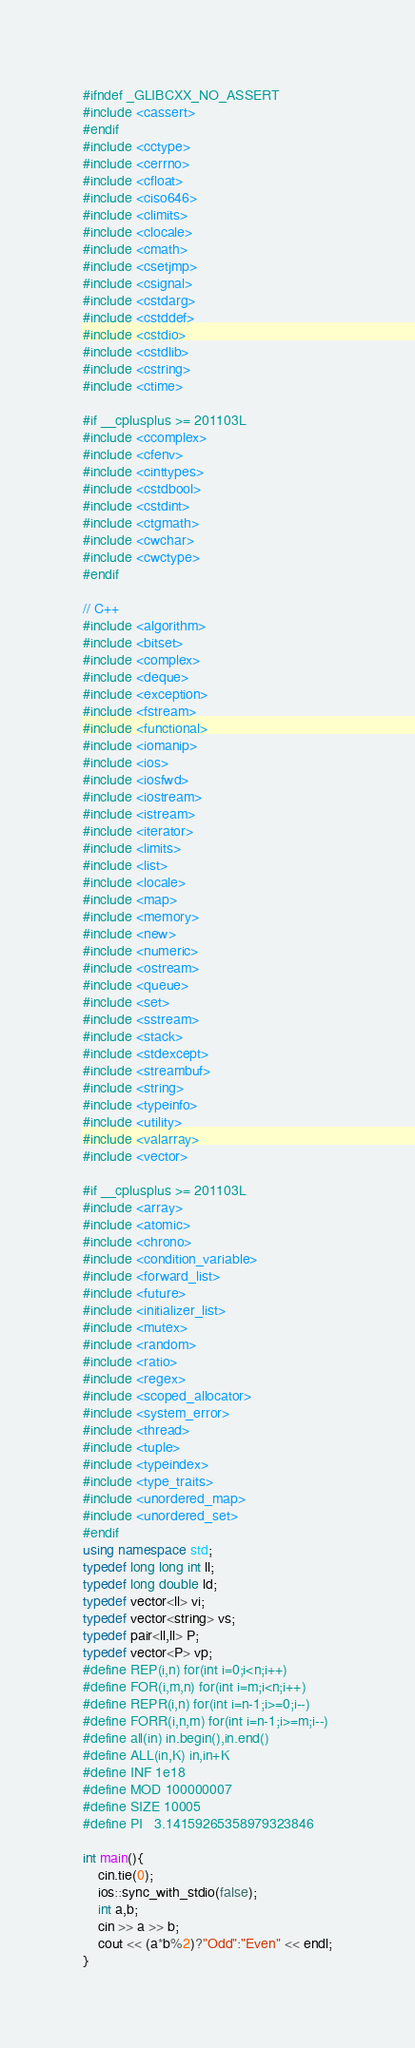Convert code to text. <code><loc_0><loc_0><loc_500><loc_500><_C++_>#ifndef _GLIBCXX_NO_ASSERT
#include <cassert>
#endif
#include <cctype>
#include <cerrno>
#include <cfloat>
#include <ciso646>
#include <climits>
#include <clocale>
#include <cmath>
#include <csetjmp>
#include <csignal>
#include <cstdarg>
#include <cstddef>
#include <cstdio>
#include <cstdlib>
#include <cstring>
#include <ctime>

#if __cplusplus >= 201103L
#include <ccomplex>
#include <cfenv>
#include <cinttypes>
#include <cstdbool>
#include <cstdint>
#include <ctgmath>
#include <cwchar>
#include <cwctype>
#endif

// C++
#include <algorithm>
#include <bitset>
#include <complex>
#include <deque>
#include <exception>
#include <fstream>
#include <functional>
#include <iomanip>
#include <ios>
#include <iosfwd>
#include <iostream>
#include <istream>
#include <iterator>
#include <limits>
#include <list>
#include <locale>
#include <map>
#include <memory>
#include <new>
#include <numeric>
#include <ostream>
#include <queue>
#include <set>
#include <sstream>
#include <stack>
#include <stdexcept>
#include <streambuf>
#include <string>
#include <typeinfo>
#include <utility>
#include <valarray>
#include <vector>

#if __cplusplus >= 201103L
#include <array>
#include <atomic>
#include <chrono>
#include <condition_variable>
#include <forward_list>
#include <future>
#include <initializer_list>
#include <mutex>
#include <random>
#include <ratio>
#include <regex>
#include <scoped_allocator>
#include <system_error>
#include <thread>
#include <tuple>
#include <typeindex>
#include <type_traits>
#include <unordered_map>
#include <unordered_set>
#endif
using namespace std;
typedef long long int ll;
typedef long double ld;
typedef vector<ll> vi;
typedef vector<string> vs;
typedef pair<ll,ll> P;
typedef vector<P> vp;
#define REP(i,n) for(int i=0;i<n;i++)
#define FOR(i,m,n) for(int i=m;i<n;i++)
#define REPR(i,n) for(int i=n-1;i>=0;i--)
#define FORR(i,n,m) for(int i=n-1;i>=m;i--)
#define all(in) in.begin(),in.end()
#define ALL(in,K) in,in+K
#define INF 1e18
#define MOD 100000007
#define SIZE 10005
#define PI 	3.14159265358979323846

int main(){
    cin.tie(0);
    ios::sync_with_stdio(false);
    int a,b;
    cin >> a >> b;
    cout << (a*b%2)?"Odd":"Even" << endl;
}
</code> 